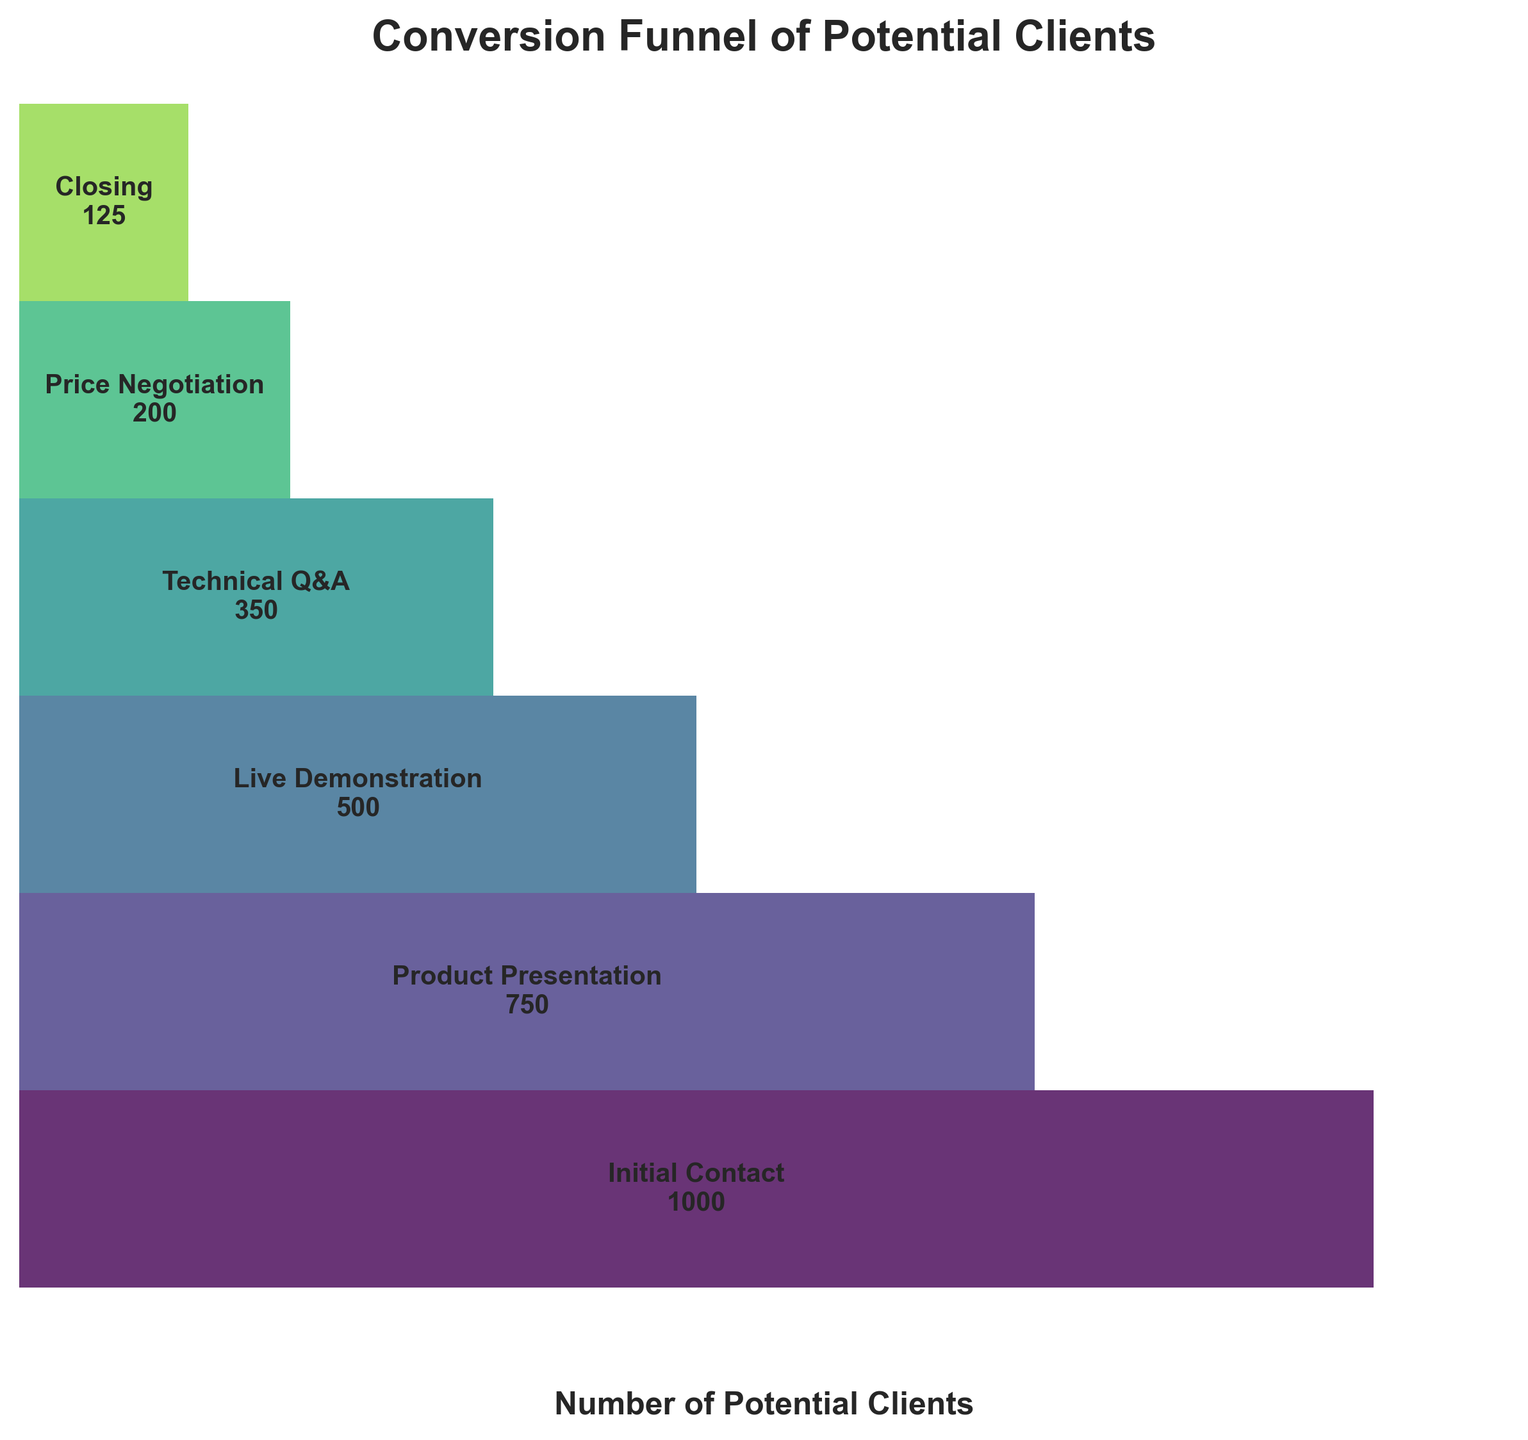what is the title of the figure? The title of the figure is located at the top of the funnel chart. It is formatted to be bold and prominent.
Answer: Conversion Funnel of Potential Clients which stage experienced the highest drop-off in potential clients? To determine the stage with the highest drop-off, calculate the difference in potential clients between each consecutive stage. The highest difference indicates the largest drop-off.
Answer: Price Negotiation how many potential clients were there after the 'Technical Q&A' stage? Refer to the stage labeled 'Technical Q&A' and look at the number next to it. This value represents the number of potential clients after this stage.
Answer: 350 compare the number of potential clients at the 'Product Presentation' stage to the 'Live Demonstration' stage. Look at the number of potential clients listed next to 'Product Presentation' and 'Live Demonstration.' Compare these two values directly to determine the difference.
Answer: 'Product Presentation' has 750 clients, 'Live Demonstration' has 500 what percentage of potential clients moved from 'Initial Contact' to 'Closing'? Calculate the percentage by dividing the number of clients at 'Closing' by the number at 'Initial Contact,' then multiply by 100. (125/1000) * 100
Answer: 12.5% which stage had more potential clients, 'Product Presentation' or 'Price Negotiation'? Compare the number of potential clients at the stages 'Product Presentation' and 'Price Negotiation' directly to see which is higher.
Answer: Product Presentation what is the average number of potential clients for all the stages? Add the number of potential clients from each stage, then divide by the total number of stages. (1000 + 750 + 500 + 350 + 200 + 125) / 6
Answer: 487.5 how many stages are there in the funnel chart? Count the distinct levels in the funnel chart, categorized from top to bottom.
Answer: 6 which stage transitioned the smallest number of potential clients to the next stage? Identify the stage by finding the smallest numerical decrease in potential clients when transitioning from one stage to the next.
Answer: Closing 